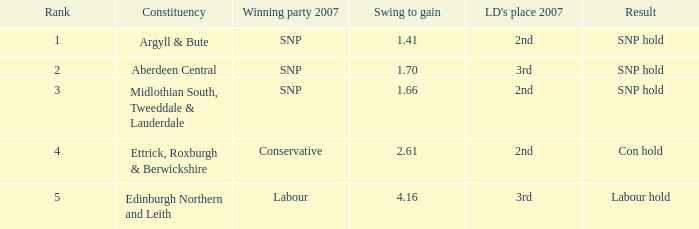What is the political division when the swing for success is less than Argyll & Bute, Midlothian South, Tweeddale & Lauderdale. 